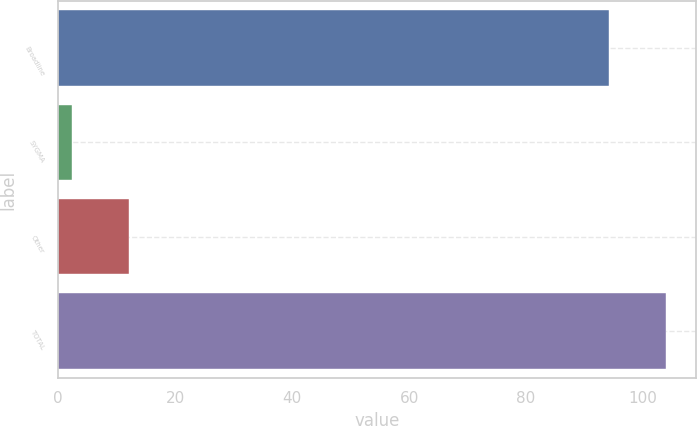<chart> <loc_0><loc_0><loc_500><loc_500><bar_chart><fcel>Broadline<fcel>SYGMA<fcel>Other<fcel>TOTAL<nl><fcel>94.1<fcel>2.4<fcel>12.16<fcel>103.86<nl></chart> 